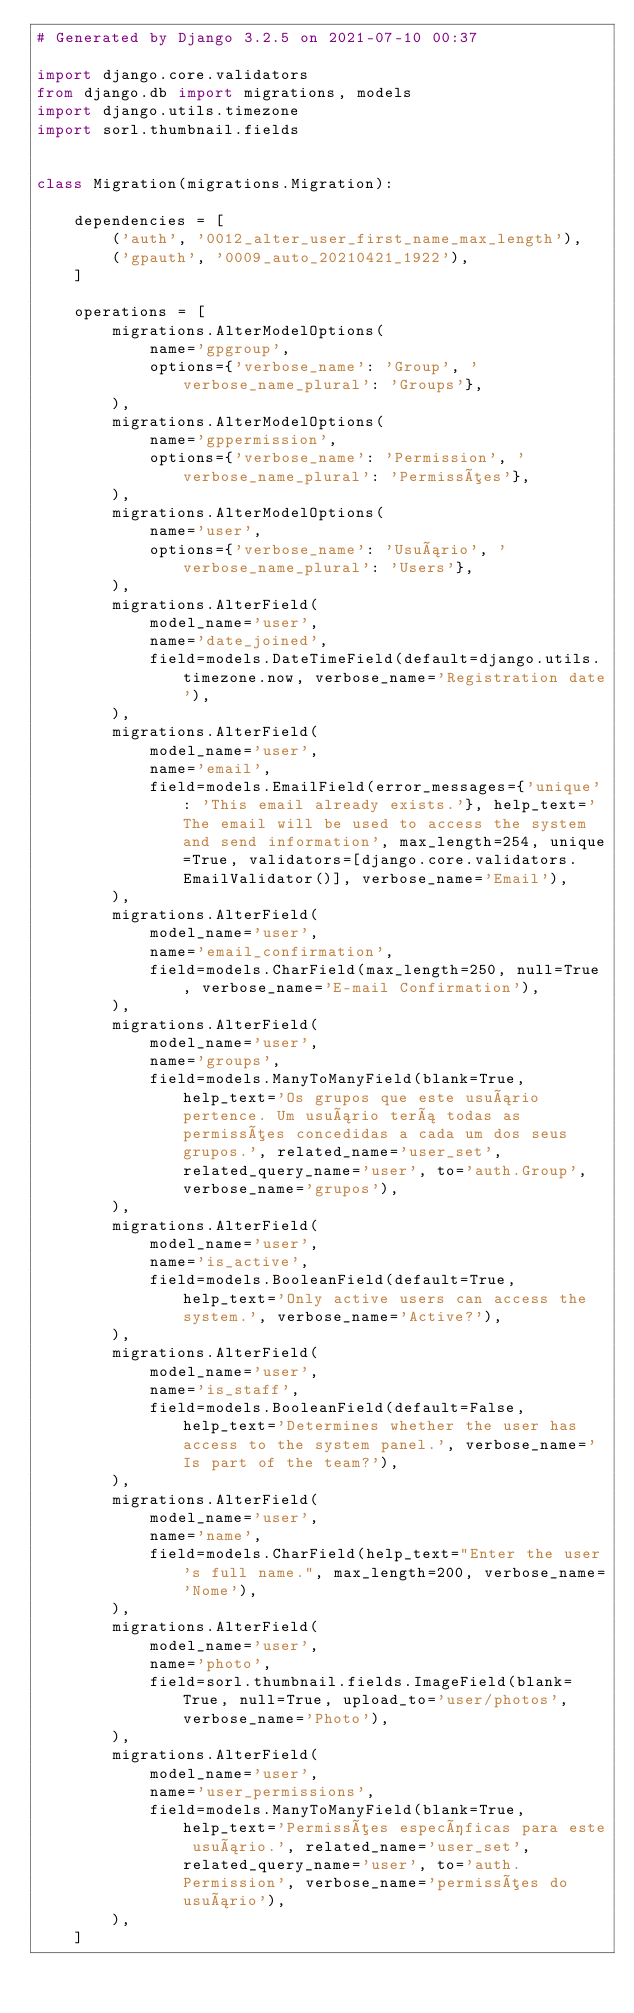<code> <loc_0><loc_0><loc_500><loc_500><_Python_># Generated by Django 3.2.5 on 2021-07-10 00:37

import django.core.validators
from django.db import migrations, models
import django.utils.timezone
import sorl.thumbnail.fields


class Migration(migrations.Migration):

    dependencies = [
        ('auth', '0012_alter_user_first_name_max_length'),
        ('gpauth', '0009_auto_20210421_1922'),
    ]

    operations = [
        migrations.AlterModelOptions(
            name='gpgroup',
            options={'verbose_name': 'Group', 'verbose_name_plural': 'Groups'},
        ),
        migrations.AlterModelOptions(
            name='gppermission',
            options={'verbose_name': 'Permission', 'verbose_name_plural': 'Permissões'},
        ),
        migrations.AlterModelOptions(
            name='user',
            options={'verbose_name': 'Usuário', 'verbose_name_plural': 'Users'},
        ),
        migrations.AlterField(
            model_name='user',
            name='date_joined',
            field=models.DateTimeField(default=django.utils.timezone.now, verbose_name='Registration date'),
        ),
        migrations.AlterField(
            model_name='user',
            name='email',
            field=models.EmailField(error_messages={'unique': 'This email already exists.'}, help_text='The email will be used to access the system and send information', max_length=254, unique=True, validators=[django.core.validators.EmailValidator()], verbose_name='Email'),
        ),
        migrations.AlterField(
            model_name='user',
            name='email_confirmation',
            field=models.CharField(max_length=250, null=True, verbose_name='E-mail Confirmation'),
        ),
        migrations.AlterField(
            model_name='user',
            name='groups',
            field=models.ManyToManyField(blank=True, help_text='Os grupos que este usuário pertence. Um usuário terá todas as permissões concedidas a cada um dos seus grupos.', related_name='user_set', related_query_name='user', to='auth.Group', verbose_name='grupos'),
        ),
        migrations.AlterField(
            model_name='user',
            name='is_active',
            field=models.BooleanField(default=True, help_text='Only active users can access the system.', verbose_name='Active?'),
        ),
        migrations.AlterField(
            model_name='user',
            name='is_staff',
            field=models.BooleanField(default=False, help_text='Determines whether the user has access to the system panel.', verbose_name='Is part of the team?'),
        ),
        migrations.AlterField(
            model_name='user',
            name='name',
            field=models.CharField(help_text="Enter the user's full name.", max_length=200, verbose_name='Nome'),
        ),
        migrations.AlterField(
            model_name='user',
            name='photo',
            field=sorl.thumbnail.fields.ImageField(blank=True, null=True, upload_to='user/photos', verbose_name='Photo'),
        ),
        migrations.AlterField(
            model_name='user',
            name='user_permissions',
            field=models.ManyToManyField(blank=True, help_text='Permissões específicas para este usuário.', related_name='user_set', related_query_name='user', to='auth.Permission', verbose_name='permissões do usuário'),
        ),
    ]
</code> 